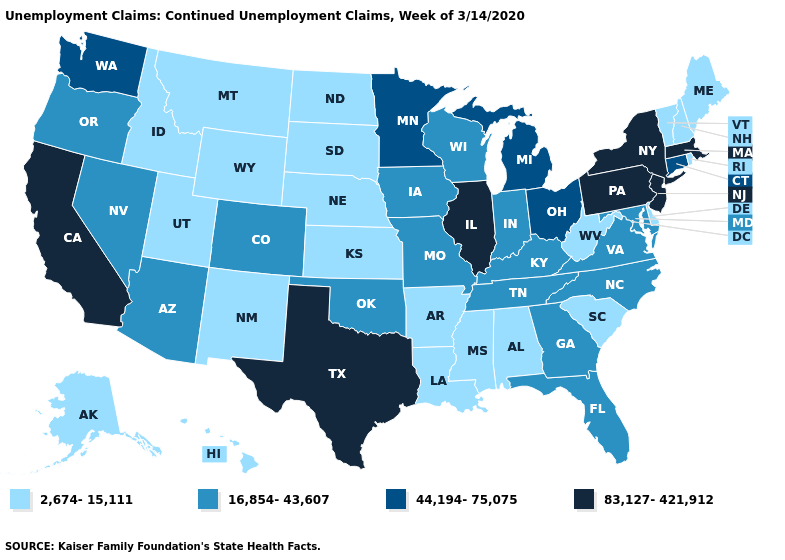Among the states that border Connecticut , which have the lowest value?
Be succinct. Rhode Island. What is the highest value in the MidWest ?
Give a very brief answer. 83,127-421,912. What is the value of Kentucky?
Quick response, please. 16,854-43,607. Is the legend a continuous bar?
Keep it brief. No. What is the value of North Carolina?
Answer briefly. 16,854-43,607. Among the states that border North Dakota , does Minnesota have the highest value?
Short answer required. Yes. What is the highest value in states that border North Carolina?
Write a very short answer. 16,854-43,607. What is the lowest value in the USA?
Keep it brief. 2,674-15,111. What is the highest value in the USA?
Be succinct. 83,127-421,912. Does Illinois have the lowest value in the MidWest?
Give a very brief answer. No. Does Virginia have a higher value than Utah?
Answer briefly. Yes. What is the highest value in states that border New Mexico?
Write a very short answer. 83,127-421,912. What is the value of Missouri?
Short answer required. 16,854-43,607. Which states have the lowest value in the West?
Concise answer only. Alaska, Hawaii, Idaho, Montana, New Mexico, Utah, Wyoming. Name the states that have a value in the range 2,674-15,111?
Be succinct. Alabama, Alaska, Arkansas, Delaware, Hawaii, Idaho, Kansas, Louisiana, Maine, Mississippi, Montana, Nebraska, New Hampshire, New Mexico, North Dakota, Rhode Island, South Carolina, South Dakota, Utah, Vermont, West Virginia, Wyoming. 